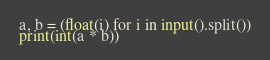Convert code to text. <code><loc_0><loc_0><loc_500><loc_500><_Python_>a, b = (float(i) for i in input().split())
print(int(a * b))
</code> 